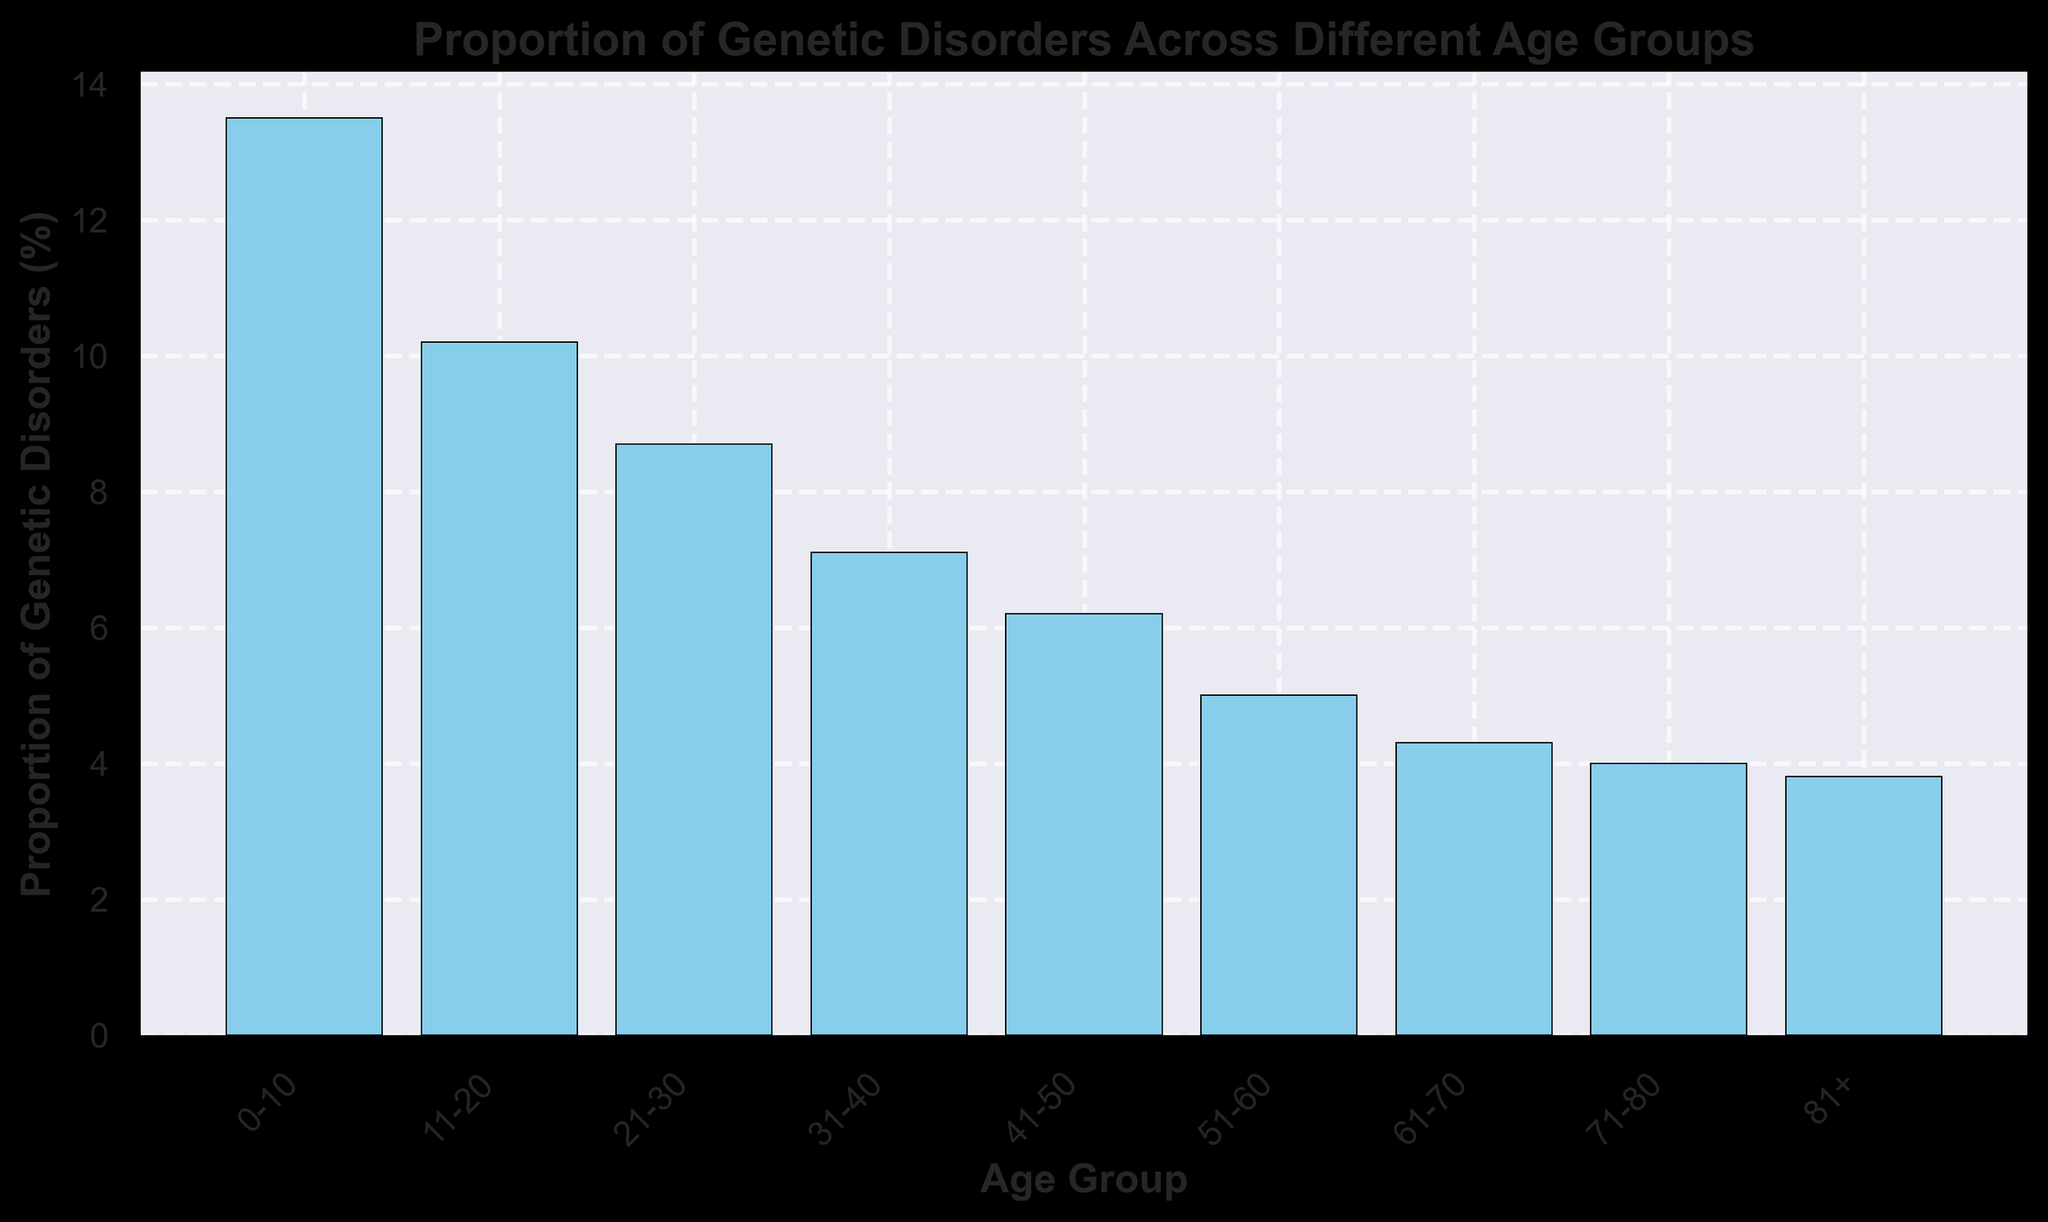What's the age group with the highest proportion of genetic disorders? To find the age group with the highest proportion of genetic disorders, look for the tallest bar in the bar chart. The 0-10 age group has the tallest bar.
Answer: 0-10 Which age group has a lower proportion of genetic disorders, 31-40 or 61-70? To compare, look at the heights of the bars for the 31-40 and 61-70 age groups. The bar for 61-70 (4.3%) is shorter than the bar for 31-40 (7.1%).
Answer: 61-70 What is the total proportion of genetic disorders for the age groups 0-10, 11-20, and 21-30 combined? Add the proportions for the age groups 0-10, 11-20, and 21-30: 13.5% + 10.2% + 8.7% = 32.4%.
Answer: 32.4% What is the difference in the proportion of genetic disorders between the 0-10 age group and the 81+ age group? Subtract the proportion of the 81+ age group from the proportion of the 0-10 age group: 13.5% - 3.8% = 9.7%.
Answer: 9.7% Is the proportion of genetic disorders for the age group 41-50 greater than that for 51-60? Compare the bars for 41-50 and 51-60. The bar for 41-50 (6.2%) is taller than the bar for 51-60 (5.0%).
Answer: Yes Which age groups have a proportion of genetic disorders greater than 5%? Identify the bars with proportions greater than 5%: 0-10, 11-20, 21-30, 31-40, and 41-50.
Answer: 0-10, 11-20, 21-30, 31-40, 41-50 What's the sum of the proportions of genetic disorders for all age groups above 60? Add the proportions for the age groups 61-70, 71-80, and 81+: 4.3% + 4.0% + 3.8% = 12.1%.
Answer: 12.1% How many age groups have a proportion of genetic disorders less than 5%? Count the bars with proportions less than 5%: 51-60, 61-70, 71-80, and 81+. There are 4 such age groups.
Answer: 4 